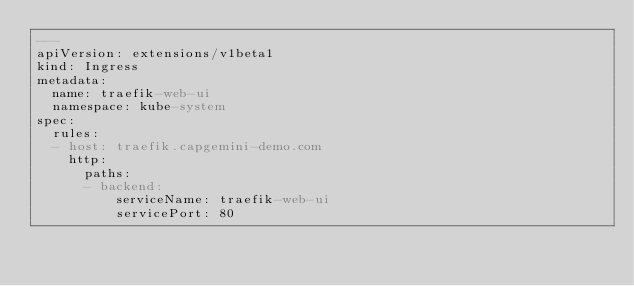Convert code to text. <code><loc_0><loc_0><loc_500><loc_500><_YAML_>---
apiVersion: extensions/v1beta1
kind: Ingress
metadata:
  name: traefik-web-ui
  namespace: kube-system
spec:
  rules:
  - host: traefik.capgemini-demo.com
    http:
      paths:
      - backend:
          serviceName: traefik-web-ui
          servicePort: 80
</code> 